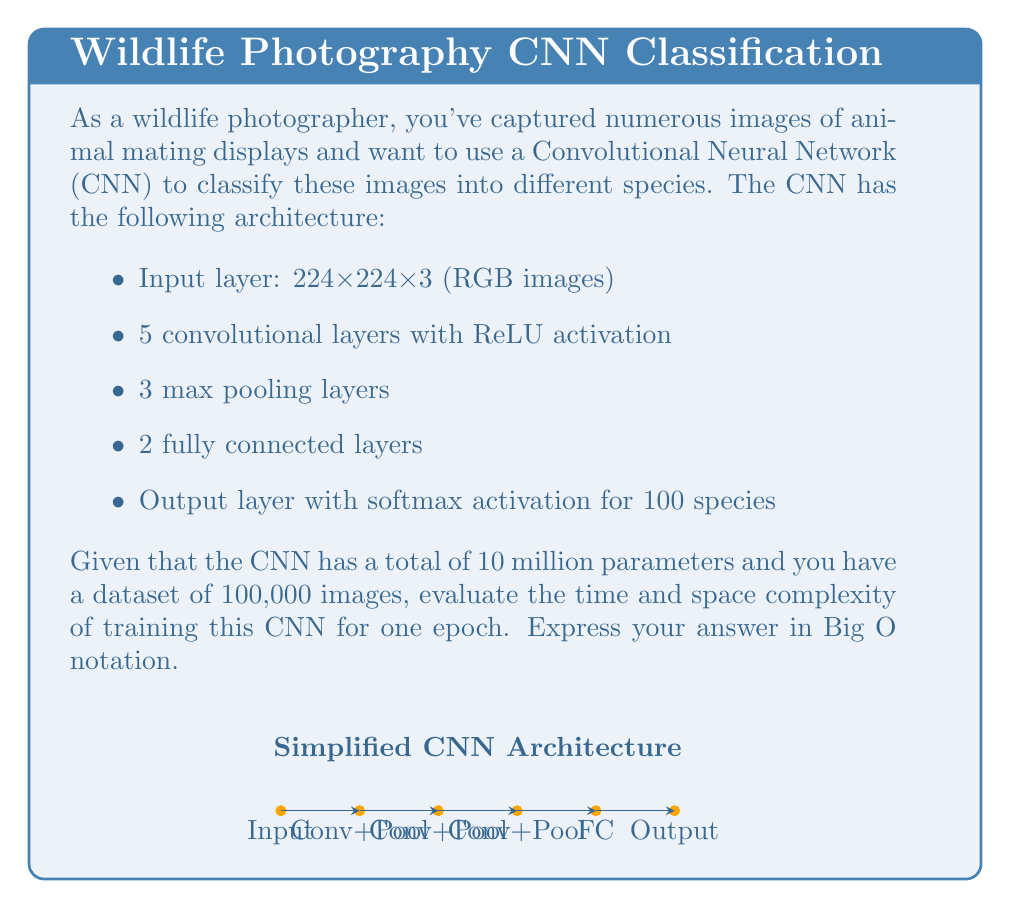Give your solution to this math problem. To evaluate the time and space complexity, let's break down the problem:

1. Time Complexity:
   a) Forward pass: For each image, we need to perform computations through all layers.
      - Convolutional layers: $O(n \cdot s^2 \cdot f^2 \cdot c_{in} \cdot c_{out})$, where $n$ is the number of layers, $s$ is the spatial dimension, $f$ is the filter size, $c_{in}$ and $c_{out}$ are input and output channels.
      - Fully connected layers: $O(m \cdot n_{in} \cdot n_{out})$, where $m$ is the number of FC layers, $n_{in}$ and $n_{out}$ are input and output neurons.
   b) Backward pass: Generally has the same complexity as the forward pass.
   c) Parameter updates: $O(p)$, where $p$ is the number of parameters.

   Total time for one image: $O(n \cdot s^2 \cdot f^2 \cdot c_{in} \cdot c_{out} + m \cdot n_{in} \cdot n_{out} + p)$

   For the entire dataset (one epoch): $O(d \cdot (n \cdot s^2 \cdot f^2 \cdot c_{in} \cdot c_{out} + m \cdot n_{in} \cdot n_{out} + p))$, where $d$ is the number of images.

2. Space Complexity:
   a) Model parameters: $O(p)$ = $O(10^7)$
   b) Activations: $O(s^2 \cdot c_{max})$, where $c_{max}$ is the maximum number of channels in any layer.
   c) Gradients: Same as model parameters, $O(p)$
   d) Input batch: $O(b \cdot s^2 \cdot c_{in})$, where $b$ is the batch size.

   Total space: $O(p + s^2 \cdot c_{max} + b \cdot s^2 \cdot c_{in})$

Simplifying and considering the dominant terms:
- Time complexity: $O(d \cdot p)$ = $O(10^5 \cdot 10^7)$ = $O(10^{12})$
- Space complexity: $O(p)$ = $O(10^7)$

Note: The actual constants and lower-order terms are omitted in Big O notation.
Answer: Time: $O(10^{12})$, Space: $O(10^7)$ 